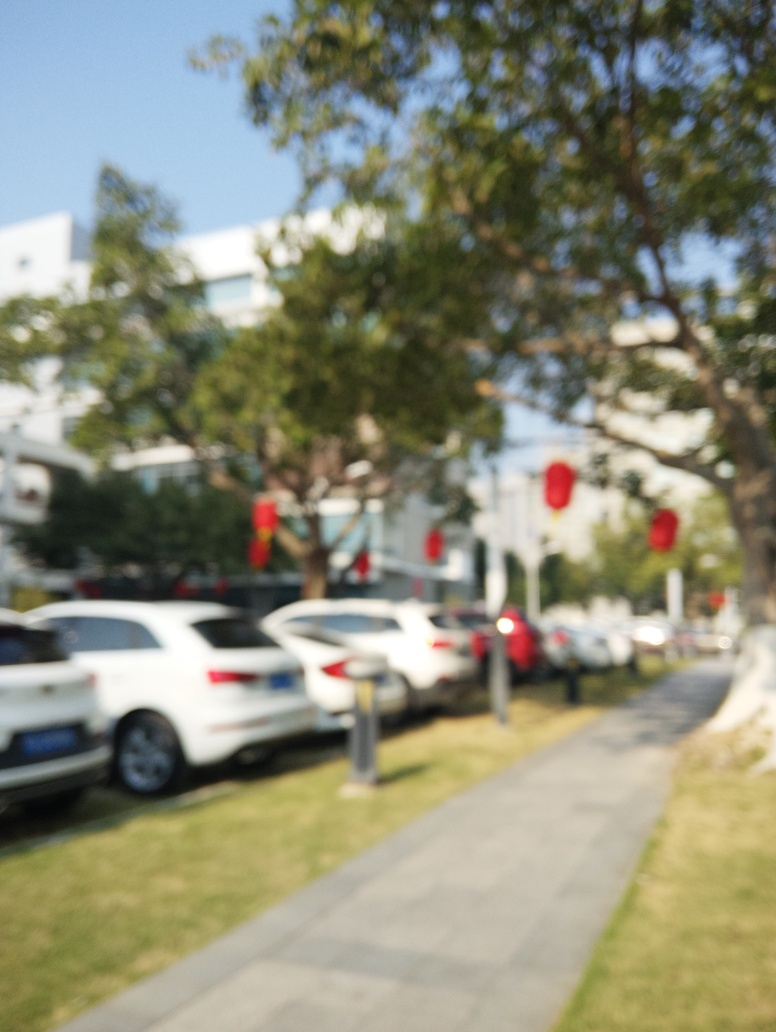Does the image have good composition? The image appears to have an unconventional composition, with a strong blur effect that obscures details and might not be intentional. Good composition typically involves clear focus and thoughtful arrangement of visual elements to guide the viewer's eye, but in this case, the effectiveness of the composition cannot be fully assessed due to the lack of sharpness. 